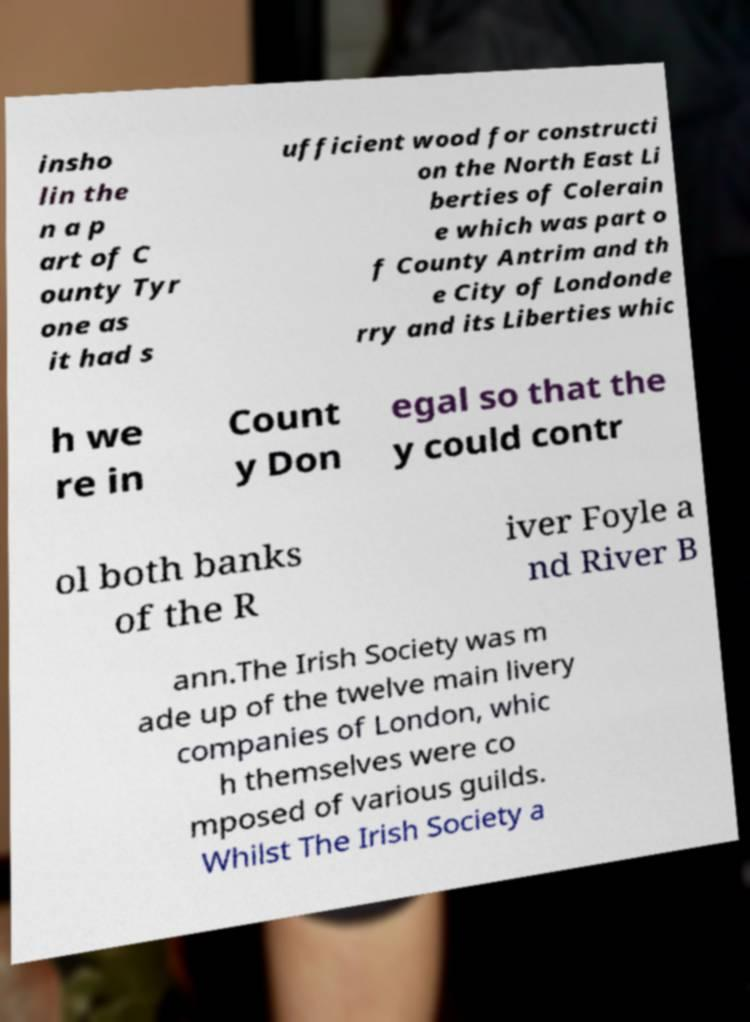Can you accurately transcribe the text from the provided image for me? insho lin the n a p art of C ounty Tyr one as it had s ufficient wood for constructi on the North East Li berties of Colerain e which was part o f County Antrim and th e City of Londonde rry and its Liberties whic h we re in Count y Don egal so that the y could contr ol both banks of the R iver Foyle a nd River B ann.The Irish Society was m ade up of the twelve main livery companies of London, whic h themselves were co mposed of various guilds. Whilst The Irish Society a 